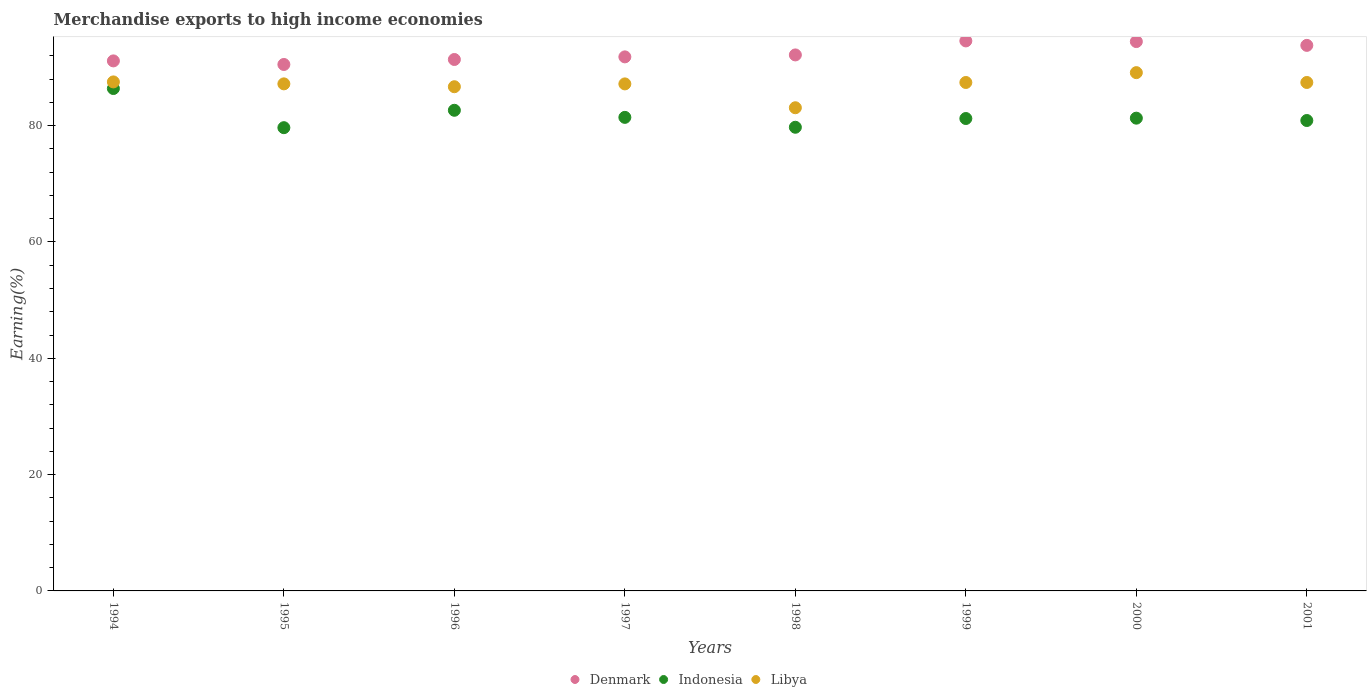What is the percentage of amount earned from merchandise exports in Denmark in 1998?
Ensure brevity in your answer.  92.16. Across all years, what is the maximum percentage of amount earned from merchandise exports in Denmark?
Keep it short and to the point. 94.57. Across all years, what is the minimum percentage of amount earned from merchandise exports in Libya?
Offer a terse response. 83.08. In which year was the percentage of amount earned from merchandise exports in Denmark minimum?
Offer a terse response. 1995. What is the total percentage of amount earned from merchandise exports in Libya in the graph?
Your answer should be very brief. 695.62. What is the difference between the percentage of amount earned from merchandise exports in Denmark in 1998 and that in 2001?
Provide a succinct answer. -1.64. What is the difference between the percentage of amount earned from merchandise exports in Libya in 1995 and the percentage of amount earned from merchandise exports in Denmark in 2000?
Offer a very short reply. -7.27. What is the average percentage of amount earned from merchandise exports in Libya per year?
Offer a very short reply. 86.95. In the year 1996, what is the difference between the percentage of amount earned from merchandise exports in Libya and percentage of amount earned from merchandise exports in Denmark?
Offer a terse response. -4.68. In how many years, is the percentage of amount earned from merchandise exports in Denmark greater than 28 %?
Offer a very short reply. 8. What is the ratio of the percentage of amount earned from merchandise exports in Denmark in 1999 to that in 2001?
Make the answer very short. 1.01. Is the difference between the percentage of amount earned from merchandise exports in Libya in 1994 and 1995 greater than the difference between the percentage of amount earned from merchandise exports in Denmark in 1994 and 1995?
Ensure brevity in your answer.  No. What is the difference between the highest and the second highest percentage of amount earned from merchandise exports in Denmark?
Give a very brief answer. 0.11. What is the difference between the highest and the lowest percentage of amount earned from merchandise exports in Denmark?
Your response must be concise. 4.05. Is the sum of the percentage of amount earned from merchandise exports in Libya in 1998 and 1999 greater than the maximum percentage of amount earned from merchandise exports in Indonesia across all years?
Offer a very short reply. Yes. Is it the case that in every year, the sum of the percentage of amount earned from merchandise exports in Denmark and percentage of amount earned from merchandise exports in Libya  is greater than the percentage of amount earned from merchandise exports in Indonesia?
Offer a very short reply. Yes. Is the percentage of amount earned from merchandise exports in Denmark strictly greater than the percentage of amount earned from merchandise exports in Indonesia over the years?
Your response must be concise. Yes. How many dotlines are there?
Your answer should be compact. 3. How many years are there in the graph?
Make the answer very short. 8. What is the difference between two consecutive major ticks on the Y-axis?
Keep it short and to the point. 20. What is the title of the graph?
Your response must be concise. Merchandise exports to high income economies. What is the label or title of the Y-axis?
Ensure brevity in your answer.  Earning(%). What is the Earning(%) of Denmark in 1994?
Make the answer very short. 91.13. What is the Earning(%) in Indonesia in 1994?
Your answer should be compact. 86.38. What is the Earning(%) in Libya in 1994?
Ensure brevity in your answer.  87.52. What is the Earning(%) of Denmark in 1995?
Offer a very short reply. 90.52. What is the Earning(%) in Indonesia in 1995?
Your answer should be compact. 79.65. What is the Earning(%) in Libya in 1995?
Make the answer very short. 87.19. What is the Earning(%) of Denmark in 1996?
Your answer should be very brief. 91.38. What is the Earning(%) of Indonesia in 1996?
Offer a terse response. 82.64. What is the Earning(%) of Libya in 1996?
Keep it short and to the point. 86.69. What is the Earning(%) in Denmark in 1997?
Provide a succinct answer. 91.83. What is the Earning(%) in Indonesia in 1997?
Provide a short and direct response. 81.42. What is the Earning(%) in Libya in 1997?
Your answer should be compact. 87.18. What is the Earning(%) in Denmark in 1998?
Provide a succinct answer. 92.16. What is the Earning(%) in Indonesia in 1998?
Provide a short and direct response. 79.72. What is the Earning(%) in Libya in 1998?
Your answer should be compact. 83.08. What is the Earning(%) in Denmark in 1999?
Provide a succinct answer. 94.57. What is the Earning(%) of Indonesia in 1999?
Offer a terse response. 81.23. What is the Earning(%) of Libya in 1999?
Make the answer very short. 87.42. What is the Earning(%) of Denmark in 2000?
Your answer should be compact. 94.46. What is the Earning(%) in Indonesia in 2000?
Keep it short and to the point. 81.29. What is the Earning(%) of Libya in 2000?
Give a very brief answer. 89.11. What is the Earning(%) of Denmark in 2001?
Your answer should be compact. 93.8. What is the Earning(%) of Indonesia in 2001?
Your answer should be very brief. 80.88. What is the Earning(%) of Libya in 2001?
Provide a succinct answer. 87.42. Across all years, what is the maximum Earning(%) in Denmark?
Provide a short and direct response. 94.57. Across all years, what is the maximum Earning(%) of Indonesia?
Provide a short and direct response. 86.38. Across all years, what is the maximum Earning(%) of Libya?
Offer a very short reply. 89.11. Across all years, what is the minimum Earning(%) of Denmark?
Ensure brevity in your answer.  90.52. Across all years, what is the minimum Earning(%) of Indonesia?
Ensure brevity in your answer.  79.65. Across all years, what is the minimum Earning(%) of Libya?
Keep it short and to the point. 83.08. What is the total Earning(%) of Denmark in the graph?
Give a very brief answer. 739.84. What is the total Earning(%) in Indonesia in the graph?
Your answer should be very brief. 653.22. What is the total Earning(%) of Libya in the graph?
Offer a terse response. 695.62. What is the difference between the Earning(%) of Denmark in 1994 and that in 1995?
Provide a short and direct response. 0.61. What is the difference between the Earning(%) in Indonesia in 1994 and that in 1995?
Keep it short and to the point. 6.73. What is the difference between the Earning(%) of Libya in 1994 and that in 1995?
Make the answer very short. 0.34. What is the difference between the Earning(%) of Denmark in 1994 and that in 1996?
Your answer should be very brief. -0.24. What is the difference between the Earning(%) in Indonesia in 1994 and that in 1996?
Your answer should be compact. 3.74. What is the difference between the Earning(%) in Libya in 1994 and that in 1996?
Make the answer very short. 0.83. What is the difference between the Earning(%) of Denmark in 1994 and that in 1997?
Your response must be concise. -0.69. What is the difference between the Earning(%) of Indonesia in 1994 and that in 1997?
Ensure brevity in your answer.  4.96. What is the difference between the Earning(%) of Libya in 1994 and that in 1997?
Give a very brief answer. 0.34. What is the difference between the Earning(%) of Denmark in 1994 and that in 1998?
Offer a very short reply. -1.03. What is the difference between the Earning(%) in Indonesia in 1994 and that in 1998?
Ensure brevity in your answer.  6.66. What is the difference between the Earning(%) of Libya in 1994 and that in 1998?
Provide a short and direct response. 4.44. What is the difference between the Earning(%) of Denmark in 1994 and that in 1999?
Ensure brevity in your answer.  -3.44. What is the difference between the Earning(%) in Indonesia in 1994 and that in 1999?
Your answer should be compact. 5.16. What is the difference between the Earning(%) in Libya in 1994 and that in 1999?
Offer a very short reply. 0.1. What is the difference between the Earning(%) of Denmark in 1994 and that in 2000?
Give a very brief answer. -3.32. What is the difference between the Earning(%) of Indonesia in 1994 and that in 2000?
Provide a succinct answer. 5.1. What is the difference between the Earning(%) of Libya in 1994 and that in 2000?
Offer a very short reply. -1.59. What is the difference between the Earning(%) of Denmark in 1994 and that in 2001?
Make the answer very short. -2.67. What is the difference between the Earning(%) of Indonesia in 1994 and that in 2001?
Your answer should be very brief. 5.5. What is the difference between the Earning(%) in Libya in 1994 and that in 2001?
Offer a terse response. 0.1. What is the difference between the Earning(%) of Denmark in 1995 and that in 1996?
Offer a terse response. -0.86. What is the difference between the Earning(%) of Indonesia in 1995 and that in 1996?
Your answer should be compact. -2.99. What is the difference between the Earning(%) of Libya in 1995 and that in 1996?
Ensure brevity in your answer.  0.49. What is the difference between the Earning(%) of Denmark in 1995 and that in 1997?
Your response must be concise. -1.31. What is the difference between the Earning(%) in Indonesia in 1995 and that in 1997?
Give a very brief answer. -1.77. What is the difference between the Earning(%) of Libya in 1995 and that in 1997?
Provide a succinct answer. 0.01. What is the difference between the Earning(%) of Denmark in 1995 and that in 1998?
Make the answer very short. -1.64. What is the difference between the Earning(%) in Indonesia in 1995 and that in 1998?
Keep it short and to the point. -0.07. What is the difference between the Earning(%) in Libya in 1995 and that in 1998?
Your answer should be very brief. 4.11. What is the difference between the Earning(%) in Denmark in 1995 and that in 1999?
Your answer should be compact. -4.05. What is the difference between the Earning(%) in Indonesia in 1995 and that in 1999?
Keep it short and to the point. -1.57. What is the difference between the Earning(%) of Libya in 1995 and that in 1999?
Offer a terse response. -0.24. What is the difference between the Earning(%) in Denmark in 1995 and that in 2000?
Provide a succinct answer. -3.94. What is the difference between the Earning(%) of Indonesia in 1995 and that in 2000?
Offer a terse response. -1.64. What is the difference between the Earning(%) of Libya in 1995 and that in 2000?
Your answer should be compact. -1.93. What is the difference between the Earning(%) in Denmark in 1995 and that in 2001?
Your answer should be compact. -3.28. What is the difference between the Earning(%) of Indonesia in 1995 and that in 2001?
Offer a very short reply. -1.23. What is the difference between the Earning(%) of Libya in 1995 and that in 2001?
Your answer should be compact. -0.24. What is the difference between the Earning(%) of Denmark in 1996 and that in 1997?
Ensure brevity in your answer.  -0.45. What is the difference between the Earning(%) in Indonesia in 1996 and that in 1997?
Ensure brevity in your answer.  1.22. What is the difference between the Earning(%) of Libya in 1996 and that in 1997?
Your answer should be very brief. -0.49. What is the difference between the Earning(%) of Denmark in 1996 and that in 1998?
Ensure brevity in your answer.  -0.79. What is the difference between the Earning(%) of Indonesia in 1996 and that in 1998?
Your response must be concise. 2.92. What is the difference between the Earning(%) of Libya in 1996 and that in 1998?
Provide a short and direct response. 3.61. What is the difference between the Earning(%) of Denmark in 1996 and that in 1999?
Provide a short and direct response. -3.19. What is the difference between the Earning(%) in Indonesia in 1996 and that in 1999?
Keep it short and to the point. 1.42. What is the difference between the Earning(%) of Libya in 1996 and that in 1999?
Keep it short and to the point. -0.73. What is the difference between the Earning(%) in Denmark in 1996 and that in 2000?
Provide a short and direct response. -3.08. What is the difference between the Earning(%) in Indonesia in 1996 and that in 2000?
Your response must be concise. 1.35. What is the difference between the Earning(%) in Libya in 1996 and that in 2000?
Your answer should be compact. -2.42. What is the difference between the Earning(%) of Denmark in 1996 and that in 2001?
Your response must be concise. -2.43. What is the difference between the Earning(%) in Indonesia in 1996 and that in 2001?
Your answer should be very brief. 1.76. What is the difference between the Earning(%) of Libya in 1996 and that in 2001?
Provide a short and direct response. -0.73. What is the difference between the Earning(%) of Denmark in 1997 and that in 1998?
Your answer should be compact. -0.34. What is the difference between the Earning(%) in Indonesia in 1997 and that in 1998?
Your answer should be compact. 1.7. What is the difference between the Earning(%) in Libya in 1997 and that in 1998?
Ensure brevity in your answer.  4.1. What is the difference between the Earning(%) in Denmark in 1997 and that in 1999?
Provide a succinct answer. -2.75. What is the difference between the Earning(%) in Indonesia in 1997 and that in 1999?
Your answer should be very brief. 0.2. What is the difference between the Earning(%) of Libya in 1997 and that in 1999?
Make the answer very short. -0.24. What is the difference between the Earning(%) of Denmark in 1997 and that in 2000?
Provide a short and direct response. -2.63. What is the difference between the Earning(%) of Indonesia in 1997 and that in 2000?
Keep it short and to the point. 0.14. What is the difference between the Earning(%) of Libya in 1997 and that in 2000?
Give a very brief answer. -1.94. What is the difference between the Earning(%) in Denmark in 1997 and that in 2001?
Ensure brevity in your answer.  -1.98. What is the difference between the Earning(%) in Indonesia in 1997 and that in 2001?
Give a very brief answer. 0.54. What is the difference between the Earning(%) of Libya in 1997 and that in 2001?
Your answer should be very brief. -0.25. What is the difference between the Earning(%) in Denmark in 1998 and that in 1999?
Your response must be concise. -2.41. What is the difference between the Earning(%) of Indonesia in 1998 and that in 1999?
Keep it short and to the point. -1.5. What is the difference between the Earning(%) in Libya in 1998 and that in 1999?
Offer a very short reply. -4.34. What is the difference between the Earning(%) of Denmark in 1998 and that in 2000?
Provide a succinct answer. -2.29. What is the difference between the Earning(%) in Indonesia in 1998 and that in 2000?
Ensure brevity in your answer.  -1.56. What is the difference between the Earning(%) of Libya in 1998 and that in 2000?
Offer a very short reply. -6.04. What is the difference between the Earning(%) of Denmark in 1998 and that in 2001?
Offer a terse response. -1.64. What is the difference between the Earning(%) of Indonesia in 1998 and that in 2001?
Offer a terse response. -1.16. What is the difference between the Earning(%) in Libya in 1998 and that in 2001?
Keep it short and to the point. -4.35. What is the difference between the Earning(%) of Denmark in 1999 and that in 2000?
Provide a succinct answer. 0.11. What is the difference between the Earning(%) of Indonesia in 1999 and that in 2000?
Offer a terse response. -0.06. What is the difference between the Earning(%) of Libya in 1999 and that in 2000?
Provide a short and direct response. -1.69. What is the difference between the Earning(%) of Denmark in 1999 and that in 2001?
Your answer should be compact. 0.77. What is the difference between the Earning(%) of Indonesia in 1999 and that in 2001?
Ensure brevity in your answer.  0.34. What is the difference between the Earning(%) in Libya in 1999 and that in 2001?
Your answer should be compact. -0. What is the difference between the Earning(%) in Denmark in 2000 and that in 2001?
Ensure brevity in your answer.  0.65. What is the difference between the Earning(%) in Indonesia in 2000 and that in 2001?
Provide a succinct answer. 0.4. What is the difference between the Earning(%) of Libya in 2000 and that in 2001?
Provide a succinct answer. 1.69. What is the difference between the Earning(%) of Denmark in 1994 and the Earning(%) of Indonesia in 1995?
Provide a succinct answer. 11.48. What is the difference between the Earning(%) of Denmark in 1994 and the Earning(%) of Libya in 1995?
Give a very brief answer. 3.95. What is the difference between the Earning(%) in Indonesia in 1994 and the Earning(%) in Libya in 1995?
Give a very brief answer. -0.8. What is the difference between the Earning(%) in Denmark in 1994 and the Earning(%) in Indonesia in 1996?
Ensure brevity in your answer.  8.49. What is the difference between the Earning(%) in Denmark in 1994 and the Earning(%) in Libya in 1996?
Provide a short and direct response. 4.44. What is the difference between the Earning(%) in Indonesia in 1994 and the Earning(%) in Libya in 1996?
Provide a short and direct response. -0.31. What is the difference between the Earning(%) in Denmark in 1994 and the Earning(%) in Indonesia in 1997?
Ensure brevity in your answer.  9.71. What is the difference between the Earning(%) of Denmark in 1994 and the Earning(%) of Libya in 1997?
Your answer should be compact. 3.96. What is the difference between the Earning(%) in Indonesia in 1994 and the Earning(%) in Libya in 1997?
Make the answer very short. -0.79. What is the difference between the Earning(%) of Denmark in 1994 and the Earning(%) of Indonesia in 1998?
Keep it short and to the point. 11.41. What is the difference between the Earning(%) of Denmark in 1994 and the Earning(%) of Libya in 1998?
Ensure brevity in your answer.  8.06. What is the difference between the Earning(%) of Indonesia in 1994 and the Earning(%) of Libya in 1998?
Give a very brief answer. 3.31. What is the difference between the Earning(%) of Denmark in 1994 and the Earning(%) of Indonesia in 1999?
Give a very brief answer. 9.91. What is the difference between the Earning(%) in Denmark in 1994 and the Earning(%) in Libya in 1999?
Your response must be concise. 3.71. What is the difference between the Earning(%) of Indonesia in 1994 and the Earning(%) of Libya in 1999?
Give a very brief answer. -1.04. What is the difference between the Earning(%) of Denmark in 1994 and the Earning(%) of Indonesia in 2000?
Provide a short and direct response. 9.85. What is the difference between the Earning(%) of Denmark in 1994 and the Earning(%) of Libya in 2000?
Provide a succinct answer. 2.02. What is the difference between the Earning(%) of Indonesia in 1994 and the Earning(%) of Libya in 2000?
Give a very brief answer. -2.73. What is the difference between the Earning(%) of Denmark in 1994 and the Earning(%) of Indonesia in 2001?
Your answer should be very brief. 10.25. What is the difference between the Earning(%) in Denmark in 1994 and the Earning(%) in Libya in 2001?
Make the answer very short. 3.71. What is the difference between the Earning(%) of Indonesia in 1994 and the Earning(%) of Libya in 2001?
Make the answer very short. -1.04. What is the difference between the Earning(%) in Denmark in 1995 and the Earning(%) in Indonesia in 1996?
Your answer should be very brief. 7.88. What is the difference between the Earning(%) of Denmark in 1995 and the Earning(%) of Libya in 1996?
Ensure brevity in your answer.  3.83. What is the difference between the Earning(%) of Indonesia in 1995 and the Earning(%) of Libya in 1996?
Make the answer very short. -7.04. What is the difference between the Earning(%) in Denmark in 1995 and the Earning(%) in Indonesia in 1997?
Provide a succinct answer. 9.09. What is the difference between the Earning(%) of Denmark in 1995 and the Earning(%) of Libya in 1997?
Your answer should be compact. 3.34. What is the difference between the Earning(%) of Indonesia in 1995 and the Earning(%) of Libya in 1997?
Keep it short and to the point. -7.53. What is the difference between the Earning(%) in Denmark in 1995 and the Earning(%) in Indonesia in 1998?
Ensure brevity in your answer.  10.8. What is the difference between the Earning(%) in Denmark in 1995 and the Earning(%) in Libya in 1998?
Your answer should be very brief. 7.44. What is the difference between the Earning(%) of Indonesia in 1995 and the Earning(%) of Libya in 1998?
Provide a succinct answer. -3.43. What is the difference between the Earning(%) of Denmark in 1995 and the Earning(%) of Indonesia in 1999?
Your answer should be compact. 9.29. What is the difference between the Earning(%) of Denmark in 1995 and the Earning(%) of Libya in 1999?
Give a very brief answer. 3.1. What is the difference between the Earning(%) in Indonesia in 1995 and the Earning(%) in Libya in 1999?
Offer a terse response. -7.77. What is the difference between the Earning(%) in Denmark in 1995 and the Earning(%) in Indonesia in 2000?
Your answer should be compact. 9.23. What is the difference between the Earning(%) in Denmark in 1995 and the Earning(%) in Libya in 2000?
Make the answer very short. 1.4. What is the difference between the Earning(%) of Indonesia in 1995 and the Earning(%) of Libya in 2000?
Provide a succinct answer. -9.46. What is the difference between the Earning(%) in Denmark in 1995 and the Earning(%) in Indonesia in 2001?
Give a very brief answer. 9.63. What is the difference between the Earning(%) in Denmark in 1995 and the Earning(%) in Libya in 2001?
Your response must be concise. 3.09. What is the difference between the Earning(%) in Indonesia in 1995 and the Earning(%) in Libya in 2001?
Provide a succinct answer. -7.77. What is the difference between the Earning(%) in Denmark in 1996 and the Earning(%) in Indonesia in 1997?
Offer a very short reply. 9.95. What is the difference between the Earning(%) in Denmark in 1996 and the Earning(%) in Libya in 1997?
Provide a short and direct response. 4.2. What is the difference between the Earning(%) in Indonesia in 1996 and the Earning(%) in Libya in 1997?
Offer a terse response. -4.54. What is the difference between the Earning(%) in Denmark in 1996 and the Earning(%) in Indonesia in 1998?
Offer a terse response. 11.65. What is the difference between the Earning(%) of Denmark in 1996 and the Earning(%) of Libya in 1998?
Your answer should be compact. 8.3. What is the difference between the Earning(%) of Indonesia in 1996 and the Earning(%) of Libya in 1998?
Your answer should be compact. -0.44. What is the difference between the Earning(%) of Denmark in 1996 and the Earning(%) of Indonesia in 1999?
Provide a short and direct response. 10.15. What is the difference between the Earning(%) in Denmark in 1996 and the Earning(%) in Libya in 1999?
Offer a terse response. 3.95. What is the difference between the Earning(%) of Indonesia in 1996 and the Earning(%) of Libya in 1999?
Ensure brevity in your answer.  -4.78. What is the difference between the Earning(%) in Denmark in 1996 and the Earning(%) in Indonesia in 2000?
Offer a terse response. 10.09. What is the difference between the Earning(%) in Denmark in 1996 and the Earning(%) in Libya in 2000?
Provide a succinct answer. 2.26. What is the difference between the Earning(%) of Indonesia in 1996 and the Earning(%) of Libya in 2000?
Provide a succinct answer. -6.47. What is the difference between the Earning(%) of Denmark in 1996 and the Earning(%) of Indonesia in 2001?
Give a very brief answer. 10.49. What is the difference between the Earning(%) in Denmark in 1996 and the Earning(%) in Libya in 2001?
Keep it short and to the point. 3.95. What is the difference between the Earning(%) in Indonesia in 1996 and the Earning(%) in Libya in 2001?
Keep it short and to the point. -4.78. What is the difference between the Earning(%) of Denmark in 1997 and the Earning(%) of Indonesia in 1998?
Provide a short and direct response. 12.1. What is the difference between the Earning(%) of Denmark in 1997 and the Earning(%) of Libya in 1998?
Provide a succinct answer. 8.75. What is the difference between the Earning(%) of Indonesia in 1997 and the Earning(%) of Libya in 1998?
Offer a terse response. -1.65. What is the difference between the Earning(%) of Denmark in 1997 and the Earning(%) of Indonesia in 1999?
Your response must be concise. 10.6. What is the difference between the Earning(%) of Denmark in 1997 and the Earning(%) of Libya in 1999?
Offer a very short reply. 4.4. What is the difference between the Earning(%) in Indonesia in 1997 and the Earning(%) in Libya in 1999?
Offer a terse response. -6. What is the difference between the Earning(%) of Denmark in 1997 and the Earning(%) of Indonesia in 2000?
Keep it short and to the point. 10.54. What is the difference between the Earning(%) of Denmark in 1997 and the Earning(%) of Libya in 2000?
Keep it short and to the point. 2.71. What is the difference between the Earning(%) of Indonesia in 1997 and the Earning(%) of Libya in 2000?
Provide a succinct answer. -7.69. What is the difference between the Earning(%) in Denmark in 1997 and the Earning(%) in Indonesia in 2001?
Make the answer very short. 10.94. What is the difference between the Earning(%) in Denmark in 1997 and the Earning(%) in Libya in 2001?
Keep it short and to the point. 4.4. What is the difference between the Earning(%) of Indonesia in 1997 and the Earning(%) of Libya in 2001?
Your answer should be very brief. -6. What is the difference between the Earning(%) of Denmark in 1998 and the Earning(%) of Indonesia in 1999?
Your answer should be very brief. 10.93. What is the difference between the Earning(%) of Denmark in 1998 and the Earning(%) of Libya in 1999?
Offer a very short reply. 4.74. What is the difference between the Earning(%) in Indonesia in 1998 and the Earning(%) in Libya in 1999?
Ensure brevity in your answer.  -7.7. What is the difference between the Earning(%) in Denmark in 1998 and the Earning(%) in Indonesia in 2000?
Your response must be concise. 10.87. What is the difference between the Earning(%) in Denmark in 1998 and the Earning(%) in Libya in 2000?
Your answer should be compact. 3.05. What is the difference between the Earning(%) in Indonesia in 1998 and the Earning(%) in Libya in 2000?
Ensure brevity in your answer.  -9.39. What is the difference between the Earning(%) in Denmark in 1998 and the Earning(%) in Indonesia in 2001?
Keep it short and to the point. 11.28. What is the difference between the Earning(%) in Denmark in 1998 and the Earning(%) in Libya in 2001?
Provide a succinct answer. 4.74. What is the difference between the Earning(%) in Indonesia in 1998 and the Earning(%) in Libya in 2001?
Make the answer very short. -7.7. What is the difference between the Earning(%) of Denmark in 1999 and the Earning(%) of Indonesia in 2000?
Make the answer very short. 13.28. What is the difference between the Earning(%) of Denmark in 1999 and the Earning(%) of Libya in 2000?
Your response must be concise. 5.46. What is the difference between the Earning(%) of Indonesia in 1999 and the Earning(%) of Libya in 2000?
Your response must be concise. -7.89. What is the difference between the Earning(%) of Denmark in 1999 and the Earning(%) of Indonesia in 2001?
Your response must be concise. 13.69. What is the difference between the Earning(%) of Denmark in 1999 and the Earning(%) of Libya in 2001?
Offer a very short reply. 7.15. What is the difference between the Earning(%) of Indonesia in 1999 and the Earning(%) of Libya in 2001?
Keep it short and to the point. -6.2. What is the difference between the Earning(%) of Denmark in 2000 and the Earning(%) of Indonesia in 2001?
Keep it short and to the point. 13.57. What is the difference between the Earning(%) of Denmark in 2000 and the Earning(%) of Libya in 2001?
Give a very brief answer. 7.03. What is the difference between the Earning(%) in Indonesia in 2000 and the Earning(%) in Libya in 2001?
Offer a terse response. -6.14. What is the average Earning(%) of Denmark per year?
Ensure brevity in your answer.  92.48. What is the average Earning(%) of Indonesia per year?
Your answer should be compact. 81.65. What is the average Earning(%) of Libya per year?
Provide a succinct answer. 86.95. In the year 1994, what is the difference between the Earning(%) in Denmark and Earning(%) in Indonesia?
Give a very brief answer. 4.75. In the year 1994, what is the difference between the Earning(%) of Denmark and Earning(%) of Libya?
Make the answer very short. 3.61. In the year 1994, what is the difference between the Earning(%) in Indonesia and Earning(%) in Libya?
Offer a very short reply. -1.14. In the year 1995, what is the difference between the Earning(%) of Denmark and Earning(%) of Indonesia?
Give a very brief answer. 10.87. In the year 1995, what is the difference between the Earning(%) of Denmark and Earning(%) of Libya?
Provide a succinct answer. 3.33. In the year 1995, what is the difference between the Earning(%) in Indonesia and Earning(%) in Libya?
Offer a terse response. -7.53. In the year 1996, what is the difference between the Earning(%) in Denmark and Earning(%) in Indonesia?
Your answer should be compact. 8.73. In the year 1996, what is the difference between the Earning(%) of Denmark and Earning(%) of Libya?
Give a very brief answer. 4.68. In the year 1996, what is the difference between the Earning(%) of Indonesia and Earning(%) of Libya?
Keep it short and to the point. -4.05. In the year 1997, what is the difference between the Earning(%) of Denmark and Earning(%) of Indonesia?
Your answer should be very brief. 10.4. In the year 1997, what is the difference between the Earning(%) of Denmark and Earning(%) of Libya?
Keep it short and to the point. 4.65. In the year 1997, what is the difference between the Earning(%) of Indonesia and Earning(%) of Libya?
Give a very brief answer. -5.75. In the year 1998, what is the difference between the Earning(%) in Denmark and Earning(%) in Indonesia?
Keep it short and to the point. 12.44. In the year 1998, what is the difference between the Earning(%) in Denmark and Earning(%) in Libya?
Your response must be concise. 9.08. In the year 1998, what is the difference between the Earning(%) of Indonesia and Earning(%) of Libya?
Keep it short and to the point. -3.36. In the year 1999, what is the difference between the Earning(%) in Denmark and Earning(%) in Indonesia?
Your answer should be compact. 13.34. In the year 1999, what is the difference between the Earning(%) of Denmark and Earning(%) of Libya?
Make the answer very short. 7.15. In the year 1999, what is the difference between the Earning(%) in Indonesia and Earning(%) in Libya?
Provide a succinct answer. -6.2. In the year 2000, what is the difference between the Earning(%) in Denmark and Earning(%) in Indonesia?
Your answer should be very brief. 13.17. In the year 2000, what is the difference between the Earning(%) of Denmark and Earning(%) of Libya?
Provide a short and direct response. 5.34. In the year 2000, what is the difference between the Earning(%) in Indonesia and Earning(%) in Libya?
Ensure brevity in your answer.  -7.83. In the year 2001, what is the difference between the Earning(%) in Denmark and Earning(%) in Indonesia?
Provide a short and direct response. 12.92. In the year 2001, what is the difference between the Earning(%) of Denmark and Earning(%) of Libya?
Keep it short and to the point. 6.38. In the year 2001, what is the difference between the Earning(%) of Indonesia and Earning(%) of Libya?
Ensure brevity in your answer.  -6.54. What is the ratio of the Earning(%) of Denmark in 1994 to that in 1995?
Your answer should be very brief. 1.01. What is the ratio of the Earning(%) of Indonesia in 1994 to that in 1995?
Your answer should be compact. 1.08. What is the ratio of the Earning(%) of Libya in 1994 to that in 1995?
Give a very brief answer. 1. What is the ratio of the Earning(%) in Denmark in 1994 to that in 1996?
Keep it short and to the point. 1. What is the ratio of the Earning(%) of Indonesia in 1994 to that in 1996?
Your answer should be compact. 1.05. What is the ratio of the Earning(%) of Libya in 1994 to that in 1996?
Offer a terse response. 1.01. What is the ratio of the Earning(%) in Denmark in 1994 to that in 1997?
Your response must be concise. 0.99. What is the ratio of the Earning(%) in Indonesia in 1994 to that in 1997?
Offer a terse response. 1.06. What is the ratio of the Earning(%) in Denmark in 1994 to that in 1998?
Provide a succinct answer. 0.99. What is the ratio of the Earning(%) in Indonesia in 1994 to that in 1998?
Your answer should be compact. 1.08. What is the ratio of the Earning(%) in Libya in 1994 to that in 1998?
Offer a very short reply. 1.05. What is the ratio of the Earning(%) in Denmark in 1994 to that in 1999?
Your answer should be compact. 0.96. What is the ratio of the Earning(%) of Indonesia in 1994 to that in 1999?
Ensure brevity in your answer.  1.06. What is the ratio of the Earning(%) in Libya in 1994 to that in 1999?
Your answer should be very brief. 1. What is the ratio of the Earning(%) of Denmark in 1994 to that in 2000?
Make the answer very short. 0.96. What is the ratio of the Earning(%) in Indonesia in 1994 to that in 2000?
Keep it short and to the point. 1.06. What is the ratio of the Earning(%) of Libya in 1994 to that in 2000?
Provide a succinct answer. 0.98. What is the ratio of the Earning(%) of Denmark in 1994 to that in 2001?
Offer a very short reply. 0.97. What is the ratio of the Earning(%) of Indonesia in 1994 to that in 2001?
Keep it short and to the point. 1.07. What is the ratio of the Earning(%) in Denmark in 1995 to that in 1996?
Keep it short and to the point. 0.99. What is the ratio of the Earning(%) in Indonesia in 1995 to that in 1996?
Provide a short and direct response. 0.96. What is the ratio of the Earning(%) in Denmark in 1995 to that in 1997?
Your response must be concise. 0.99. What is the ratio of the Earning(%) of Indonesia in 1995 to that in 1997?
Ensure brevity in your answer.  0.98. What is the ratio of the Earning(%) in Denmark in 1995 to that in 1998?
Your answer should be very brief. 0.98. What is the ratio of the Earning(%) in Indonesia in 1995 to that in 1998?
Your answer should be compact. 1. What is the ratio of the Earning(%) in Libya in 1995 to that in 1998?
Give a very brief answer. 1.05. What is the ratio of the Earning(%) in Denmark in 1995 to that in 1999?
Provide a short and direct response. 0.96. What is the ratio of the Earning(%) of Indonesia in 1995 to that in 1999?
Provide a short and direct response. 0.98. What is the ratio of the Earning(%) in Denmark in 1995 to that in 2000?
Make the answer very short. 0.96. What is the ratio of the Earning(%) of Indonesia in 1995 to that in 2000?
Ensure brevity in your answer.  0.98. What is the ratio of the Earning(%) of Libya in 1995 to that in 2000?
Your answer should be very brief. 0.98. What is the ratio of the Earning(%) in Indonesia in 1995 to that in 2001?
Your response must be concise. 0.98. What is the ratio of the Earning(%) of Denmark in 1996 to that in 1997?
Offer a terse response. 1. What is the ratio of the Earning(%) of Indonesia in 1996 to that in 1997?
Offer a terse response. 1.01. What is the ratio of the Earning(%) in Indonesia in 1996 to that in 1998?
Keep it short and to the point. 1.04. What is the ratio of the Earning(%) in Libya in 1996 to that in 1998?
Offer a very short reply. 1.04. What is the ratio of the Earning(%) of Denmark in 1996 to that in 1999?
Your answer should be very brief. 0.97. What is the ratio of the Earning(%) in Indonesia in 1996 to that in 1999?
Provide a short and direct response. 1.02. What is the ratio of the Earning(%) of Libya in 1996 to that in 1999?
Keep it short and to the point. 0.99. What is the ratio of the Earning(%) of Denmark in 1996 to that in 2000?
Your response must be concise. 0.97. What is the ratio of the Earning(%) in Indonesia in 1996 to that in 2000?
Offer a terse response. 1.02. What is the ratio of the Earning(%) of Libya in 1996 to that in 2000?
Provide a short and direct response. 0.97. What is the ratio of the Earning(%) of Denmark in 1996 to that in 2001?
Give a very brief answer. 0.97. What is the ratio of the Earning(%) of Indonesia in 1996 to that in 2001?
Keep it short and to the point. 1.02. What is the ratio of the Earning(%) in Indonesia in 1997 to that in 1998?
Offer a terse response. 1.02. What is the ratio of the Earning(%) in Libya in 1997 to that in 1998?
Make the answer very short. 1.05. What is the ratio of the Earning(%) in Indonesia in 1997 to that in 1999?
Provide a short and direct response. 1. What is the ratio of the Earning(%) in Denmark in 1997 to that in 2000?
Your answer should be very brief. 0.97. What is the ratio of the Earning(%) in Libya in 1997 to that in 2000?
Give a very brief answer. 0.98. What is the ratio of the Earning(%) in Denmark in 1997 to that in 2001?
Provide a short and direct response. 0.98. What is the ratio of the Earning(%) of Denmark in 1998 to that in 1999?
Provide a short and direct response. 0.97. What is the ratio of the Earning(%) of Indonesia in 1998 to that in 1999?
Keep it short and to the point. 0.98. What is the ratio of the Earning(%) in Libya in 1998 to that in 1999?
Provide a succinct answer. 0.95. What is the ratio of the Earning(%) in Denmark in 1998 to that in 2000?
Provide a short and direct response. 0.98. What is the ratio of the Earning(%) of Indonesia in 1998 to that in 2000?
Ensure brevity in your answer.  0.98. What is the ratio of the Earning(%) in Libya in 1998 to that in 2000?
Keep it short and to the point. 0.93. What is the ratio of the Earning(%) of Denmark in 1998 to that in 2001?
Offer a very short reply. 0.98. What is the ratio of the Earning(%) of Indonesia in 1998 to that in 2001?
Provide a succinct answer. 0.99. What is the ratio of the Earning(%) in Libya in 1998 to that in 2001?
Offer a terse response. 0.95. What is the ratio of the Earning(%) in Denmark in 1999 to that in 2000?
Your answer should be very brief. 1. What is the ratio of the Earning(%) in Indonesia in 1999 to that in 2000?
Provide a short and direct response. 1. What is the ratio of the Earning(%) of Libya in 1999 to that in 2000?
Provide a succinct answer. 0.98. What is the ratio of the Earning(%) of Denmark in 1999 to that in 2001?
Ensure brevity in your answer.  1.01. What is the ratio of the Earning(%) in Libya in 1999 to that in 2001?
Offer a very short reply. 1. What is the ratio of the Earning(%) of Denmark in 2000 to that in 2001?
Offer a very short reply. 1.01. What is the ratio of the Earning(%) in Indonesia in 2000 to that in 2001?
Provide a short and direct response. 1. What is the ratio of the Earning(%) of Libya in 2000 to that in 2001?
Provide a succinct answer. 1.02. What is the difference between the highest and the second highest Earning(%) in Denmark?
Your answer should be compact. 0.11. What is the difference between the highest and the second highest Earning(%) of Indonesia?
Your answer should be compact. 3.74. What is the difference between the highest and the second highest Earning(%) in Libya?
Ensure brevity in your answer.  1.59. What is the difference between the highest and the lowest Earning(%) in Denmark?
Offer a very short reply. 4.05. What is the difference between the highest and the lowest Earning(%) in Indonesia?
Offer a terse response. 6.73. What is the difference between the highest and the lowest Earning(%) in Libya?
Ensure brevity in your answer.  6.04. 